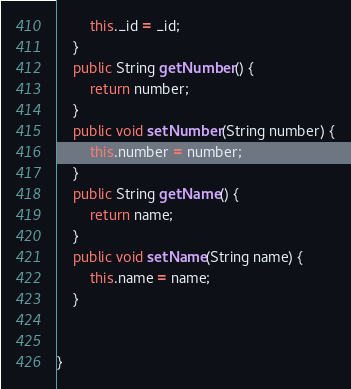<code> <loc_0><loc_0><loc_500><loc_500><_Java_>		this._id = _id;
	}
	public String getNumber() {
		return number;
	}
	public void setNumber(String number) {
		this.number = number;
	}
	public String getName() {
		return name;
	}
	public void setName(String name) {
		this.name = name;
	} 
	
	
}
</code> 